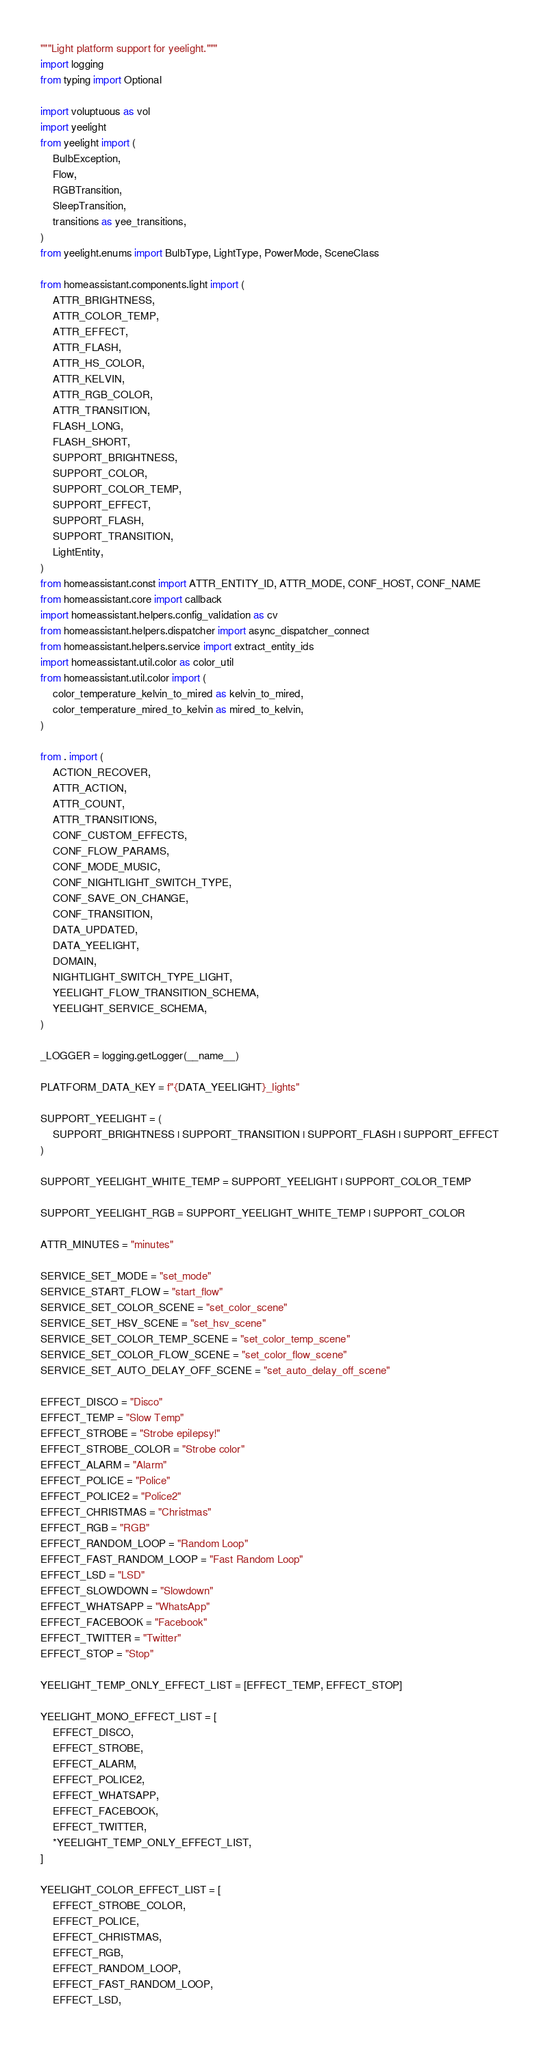<code> <loc_0><loc_0><loc_500><loc_500><_Python_>"""Light platform support for yeelight."""
import logging
from typing import Optional

import voluptuous as vol
import yeelight
from yeelight import (
    BulbException,
    Flow,
    RGBTransition,
    SleepTransition,
    transitions as yee_transitions,
)
from yeelight.enums import BulbType, LightType, PowerMode, SceneClass

from homeassistant.components.light import (
    ATTR_BRIGHTNESS,
    ATTR_COLOR_TEMP,
    ATTR_EFFECT,
    ATTR_FLASH,
    ATTR_HS_COLOR,
    ATTR_KELVIN,
    ATTR_RGB_COLOR,
    ATTR_TRANSITION,
    FLASH_LONG,
    FLASH_SHORT,
    SUPPORT_BRIGHTNESS,
    SUPPORT_COLOR,
    SUPPORT_COLOR_TEMP,
    SUPPORT_EFFECT,
    SUPPORT_FLASH,
    SUPPORT_TRANSITION,
    LightEntity,
)
from homeassistant.const import ATTR_ENTITY_ID, ATTR_MODE, CONF_HOST, CONF_NAME
from homeassistant.core import callback
import homeassistant.helpers.config_validation as cv
from homeassistant.helpers.dispatcher import async_dispatcher_connect
from homeassistant.helpers.service import extract_entity_ids
import homeassistant.util.color as color_util
from homeassistant.util.color import (
    color_temperature_kelvin_to_mired as kelvin_to_mired,
    color_temperature_mired_to_kelvin as mired_to_kelvin,
)

from . import (
    ACTION_RECOVER,
    ATTR_ACTION,
    ATTR_COUNT,
    ATTR_TRANSITIONS,
    CONF_CUSTOM_EFFECTS,
    CONF_FLOW_PARAMS,
    CONF_MODE_MUSIC,
    CONF_NIGHTLIGHT_SWITCH_TYPE,
    CONF_SAVE_ON_CHANGE,
    CONF_TRANSITION,
    DATA_UPDATED,
    DATA_YEELIGHT,
    DOMAIN,
    NIGHTLIGHT_SWITCH_TYPE_LIGHT,
    YEELIGHT_FLOW_TRANSITION_SCHEMA,
    YEELIGHT_SERVICE_SCHEMA,
)

_LOGGER = logging.getLogger(__name__)

PLATFORM_DATA_KEY = f"{DATA_YEELIGHT}_lights"

SUPPORT_YEELIGHT = (
    SUPPORT_BRIGHTNESS | SUPPORT_TRANSITION | SUPPORT_FLASH | SUPPORT_EFFECT
)

SUPPORT_YEELIGHT_WHITE_TEMP = SUPPORT_YEELIGHT | SUPPORT_COLOR_TEMP

SUPPORT_YEELIGHT_RGB = SUPPORT_YEELIGHT_WHITE_TEMP | SUPPORT_COLOR

ATTR_MINUTES = "minutes"

SERVICE_SET_MODE = "set_mode"
SERVICE_START_FLOW = "start_flow"
SERVICE_SET_COLOR_SCENE = "set_color_scene"
SERVICE_SET_HSV_SCENE = "set_hsv_scene"
SERVICE_SET_COLOR_TEMP_SCENE = "set_color_temp_scene"
SERVICE_SET_COLOR_FLOW_SCENE = "set_color_flow_scene"
SERVICE_SET_AUTO_DELAY_OFF_SCENE = "set_auto_delay_off_scene"

EFFECT_DISCO = "Disco"
EFFECT_TEMP = "Slow Temp"
EFFECT_STROBE = "Strobe epilepsy!"
EFFECT_STROBE_COLOR = "Strobe color"
EFFECT_ALARM = "Alarm"
EFFECT_POLICE = "Police"
EFFECT_POLICE2 = "Police2"
EFFECT_CHRISTMAS = "Christmas"
EFFECT_RGB = "RGB"
EFFECT_RANDOM_LOOP = "Random Loop"
EFFECT_FAST_RANDOM_LOOP = "Fast Random Loop"
EFFECT_LSD = "LSD"
EFFECT_SLOWDOWN = "Slowdown"
EFFECT_WHATSAPP = "WhatsApp"
EFFECT_FACEBOOK = "Facebook"
EFFECT_TWITTER = "Twitter"
EFFECT_STOP = "Stop"

YEELIGHT_TEMP_ONLY_EFFECT_LIST = [EFFECT_TEMP, EFFECT_STOP]

YEELIGHT_MONO_EFFECT_LIST = [
    EFFECT_DISCO,
    EFFECT_STROBE,
    EFFECT_ALARM,
    EFFECT_POLICE2,
    EFFECT_WHATSAPP,
    EFFECT_FACEBOOK,
    EFFECT_TWITTER,
    *YEELIGHT_TEMP_ONLY_EFFECT_LIST,
]

YEELIGHT_COLOR_EFFECT_LIST = [
    EFFECT_STROBE_COLOR,
    EFFECT_POLICE,
    EFFECT_CHRISTMAS,
    EFFECT_RGB,
    EFFECT_RANDOM_LOOP,
    EFFECT_FAST_RANDOM_LOOP,
    EFFECT_LSD,</code> 